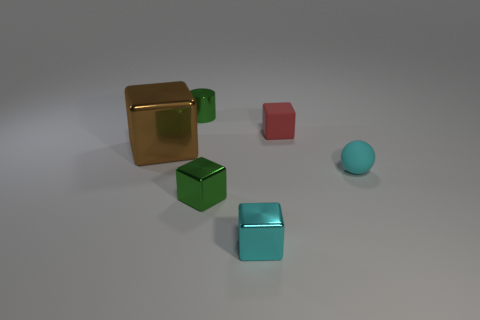Add 3 small cyan shiny objects. How many objects exist? 9 Subtract all cubes. How many objects are left? 2 Add 2 large brown metal things. How many large brown metal things are left? 3 Add 3 red things. How many red things exist? 4 Subtract 1 green blocks. How many objects are left? 5 Subtract all brown cubes. Subtract all red cubes. How many objects are left? 4 